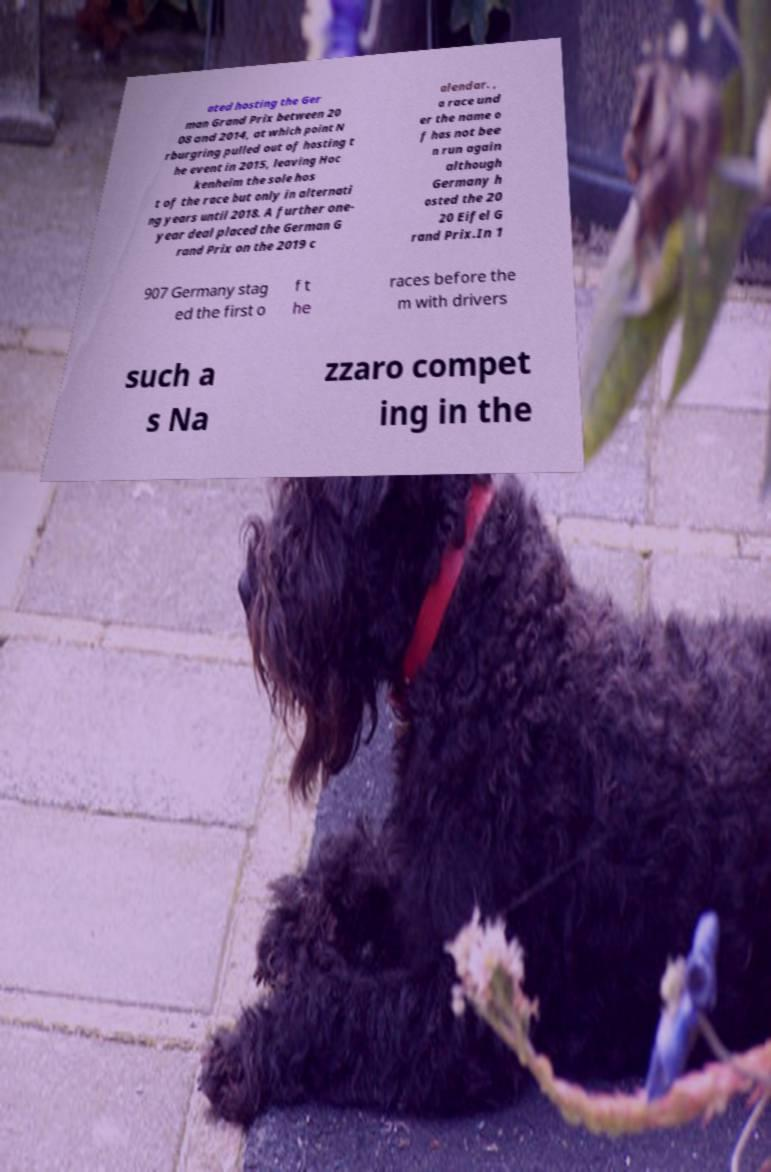Please read and relay the text visible in this image. What does it say? ated hosting the Ger man Grand Prix between 20 08 and 2014, at which point N rburgring pulled out of hosting t he event in 2015, leaving Hoc kenheim the sole hos t of the race but only in alternati ng years until 2018. A further one- year deal placed the German G rand Prix on the 2019 c alendar. , a race und er the name o f has not bee n run again although Germany h osted the 20 20 Eifel G rand Prix.In 1 907 Germany stag ed the first o f t he races before the m with drivers such a s Na zzaro compet ing in the 